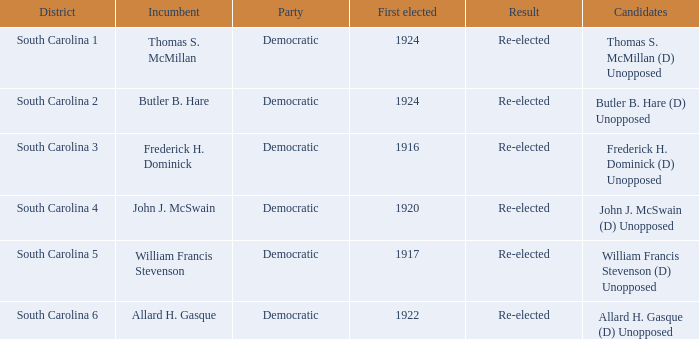In what year was william francis stevenson's first election? 1917.0. 